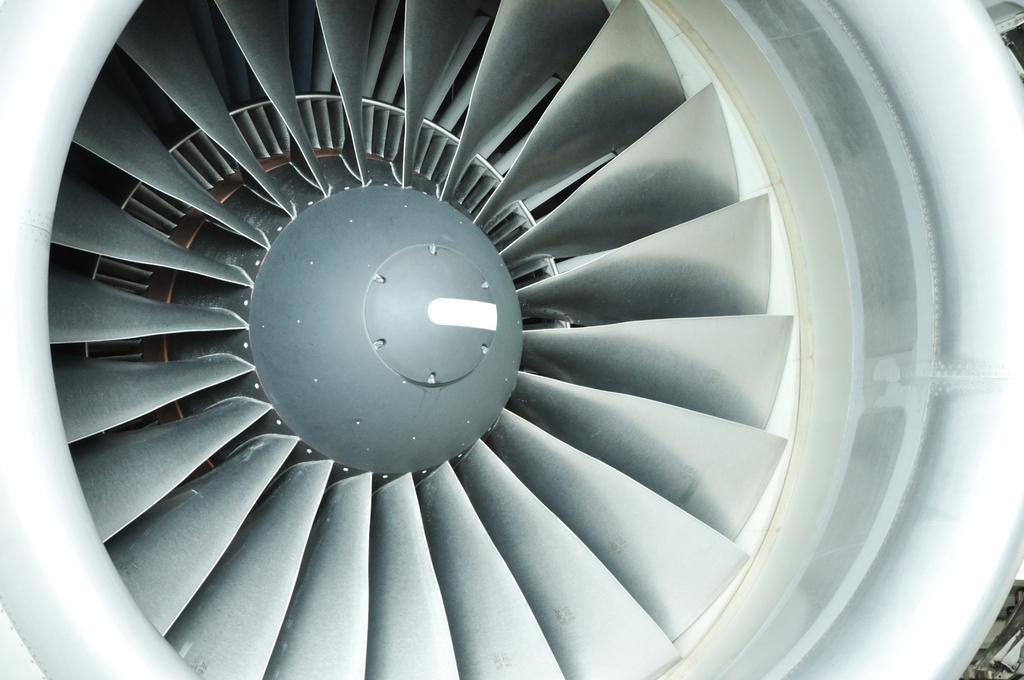Please provide a concise description of this image. In this image we can see the turbine jet engine. 